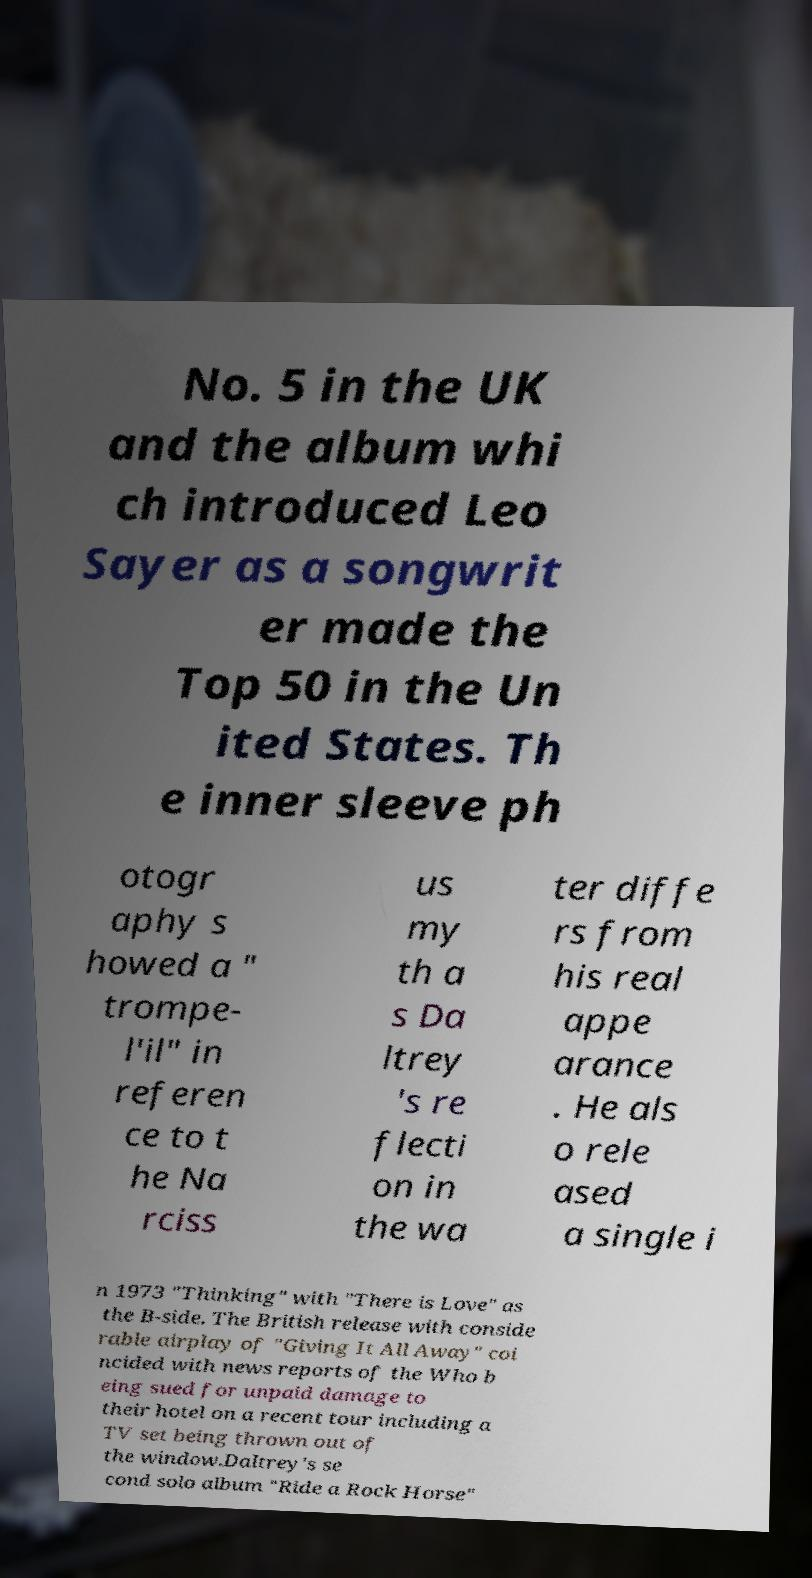Please read and relay the text visible in this image. What does it say? No. 5 in the UK and the album whi ch introduced Leo Sayer as a songwrit er made the Top 50 in the Un ited States. Th e inner sleeve ph otogr aphy s howed a " trompe- l'il" in referen ce to t he Na rciss us my th a s Da ltrey 's re flecti on in the wa ter diffe rs from his real appe arance . He als o rele ased a single i n 1973 "Thinking" with "There is Love" as the B-side. The British release with conside rable airplay of "Giving It All Away" coi ncided with news reports of the Who b eing sued for unpaid damage to their hotel on a recent tour including a TV set being thrown out of the window.Daltrey's se cond solo album "Ride a Rock Horse" 